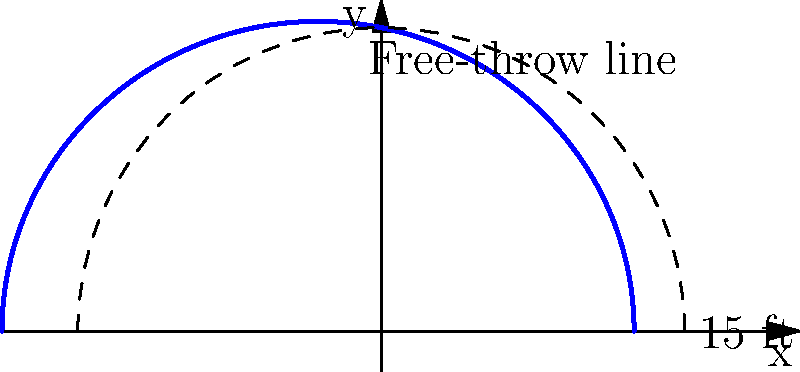The Cameron Crazies want to paint a unique free-throw line for Duke's home court. The new line is defined in polar coordinates by the equation $r = \frac{15}{1 + 0.2\cos(\theta)}$, where $r$ is in feet. Calculate the arc length of this curved free-throw line from $\theta = 0$ to $\theta = \pi$. To find the arc length of the curved free-throw line, we'll use the formula for arc length in polar coordinates:

$$ L = \int_a^b \sqrt{r^2 + \left(\frac{dr}{d\theta}\right)^2} d\theta $$

Step 1: Calculate $\frac{dr}{d\theta}$
$$ r = \frac{15}{1 + 0.2\cos(\theta)} $$
$$ \frac{dr}{d\theta} = \frac{15 \cdot 0.2\sin(\theta)}{(1 + 0.2\cos(\theta))^2} $$

Step 2: Substitute into the arc length formula
$$ L = \int_0^\pi \sqrt{\left(\frac{15}{1 + 0.2\cos(\theta)}\right)^2 + \left(\frac{15 \cdot 0.2\sin(\theta)}{(1 + 0.2\cos(\theta))^2}\right)^2} d\theta $$

Step 3: Simplify the integrand
$$ L = \int_0^\pi \frac{15\sqrt{1 + 0.04\sin^2(\theta)}}{1 + 0.2\cos(\theta)} d\theta $$

Step 4: This integral cannot be evaluated analytically, so we need to use numerical integration. Using a calculator or computer algebra system, we can approximate the integral:

$$ L \approx 15.71 \text{ feet} $$

This result shows that the curved free-throw line is slightly longer than the standard 15-foot straight line.
Answer: 15.71 feet 